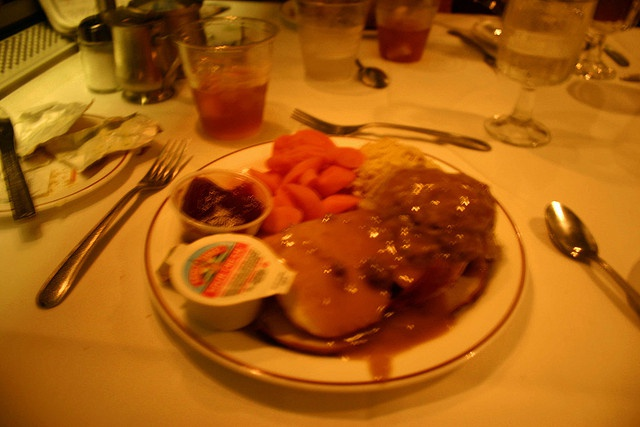Describe the objects in this image and their specific colors. I can see dining table in black, orange, red, and maroon tones, cup in black, brown, and maroon tones, wine glass in black, brown, orange, and maroon tones, cup in black, orange, red, and maroon tones, and carrot in black, red, brown, and maroon tones in this image. 